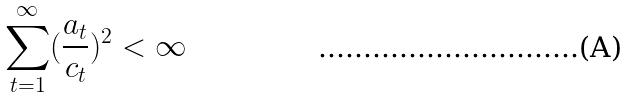Convert formula to latex. <formula><loc_0><loc_0><loc_500><loc_500>\sum _ { t = 1 } ^ { \infty } ( \frac { a _ { t } } { c _ { t } } ) ^ { 2 } < \infty</formula> 